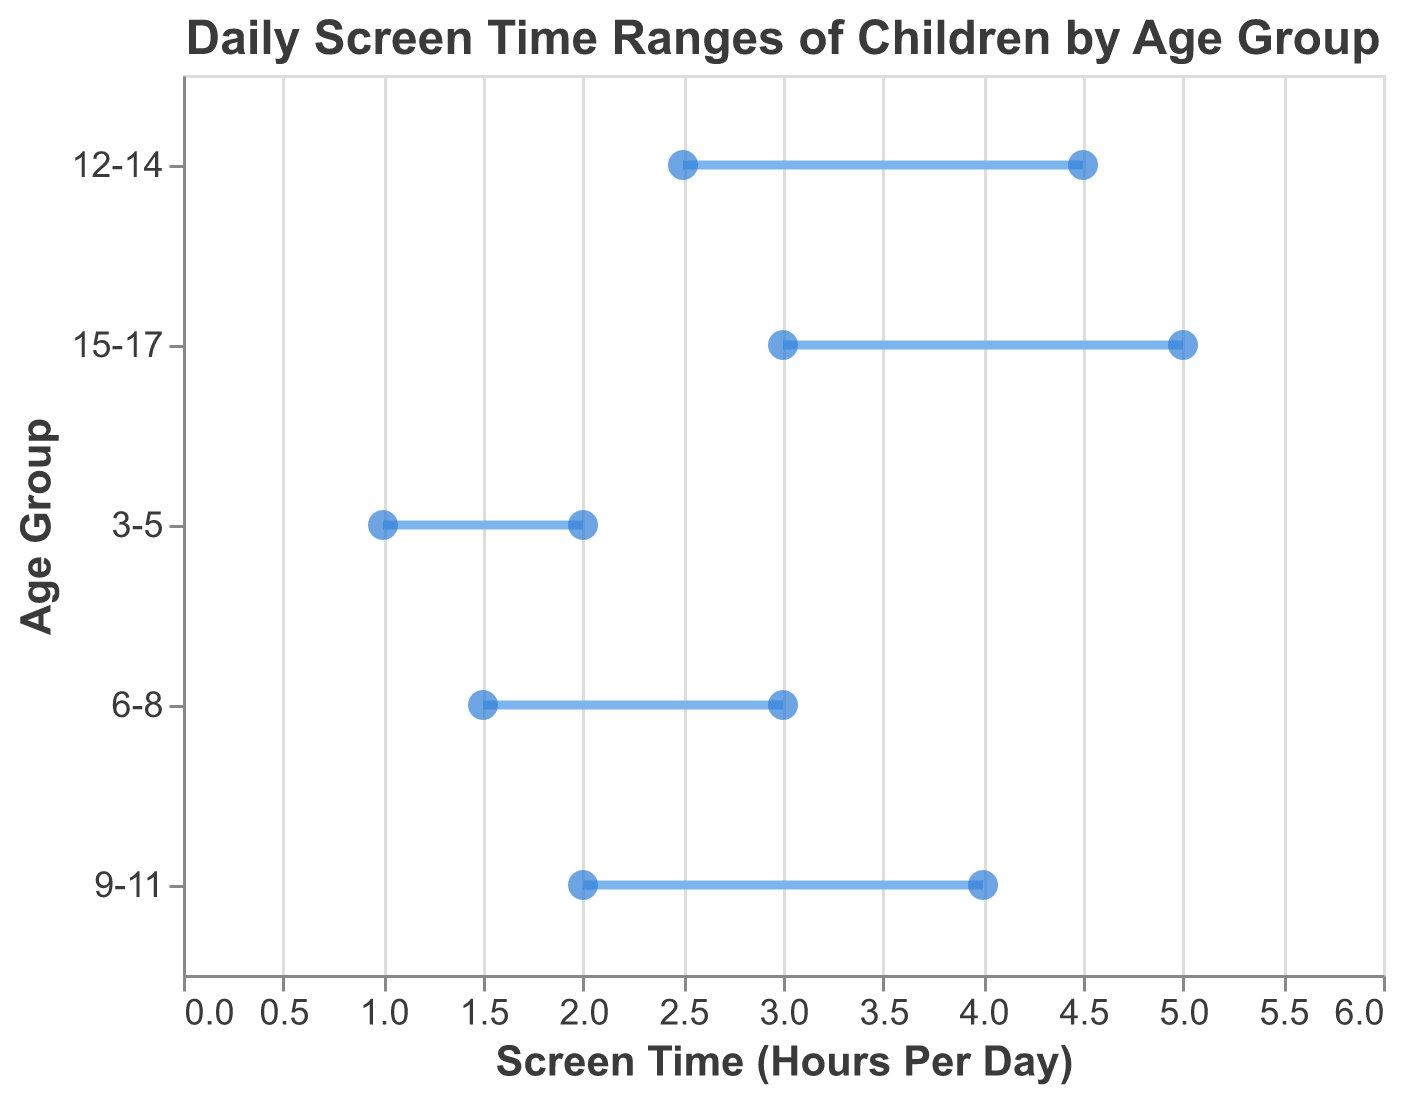What is the title of the figure? The title is located at the top of the figure, and it simply states the main topic of the plot.
Answer: Daily Screen Time Ranges of Children by Age Group What are the axes titles on the plot? The x-axis title indicates the measure being plotted along the horizontal axis, and the y-axis title indicates the categories being compared along the vertical axis.
Answer: Screen Time (Hours Per Day), Age Group Which age group has the highest maximum screen time? By looking at the rightmost points along the x-axis for each age group, we can see that the 15-17 age group extends the furthest to the right.
Answer: 15-17 What is the minimum screen time for the 9-11 age group? The minimum screen time is represented by the leftmost point on the horizontal axis for the 9-11 age group.
Answer: 2 hours How do the screen time ranges change as the age group increases? By observing the plot, we can see that both the minimum and maximum screen time values increase as the age groups get older. This trend suggests that older children tend to have more screen time.
Answer: Both the minimum and maximum values increase What is the difference in maximum screen time between the 3-5 and 15-17 age groups? To find the difference, subtract the maximum screen time value of the 3-5 age group from that of the 15-17 age group.
Answer: 5 - 2 = 3 hours Which age group has the smallest range of screen time? The range of screen time is represented by the distance between the minimum and maximum points for each age group. The 3-5 age group has the smallest range.
Answer: 3-5 Between which two age groups is the increase in maximum screen time the largest? By examining the differences in maximum screen time between consecutive age groups, we find that the increase is largest between the 12-14 and 15-17 age groups (4.5 to 5).
Answer: Between 12-14 and 15-17 What is the average maximum screen time across all age groups? To calculate this, sum up the maximum screen time values for all age groups and divide by the number of age groups. (2 + 3 + 4 + 4.5 + 5) / 5 = 3.7
Answer: 3.7 hours What is the median minimum screen time across all age groups? First, list the minimum screen time values in ascending order: 1, 1.5, 2, 2.5, 3. The median value is the one in the middle of this ordered list.
Answer: 2 hours 